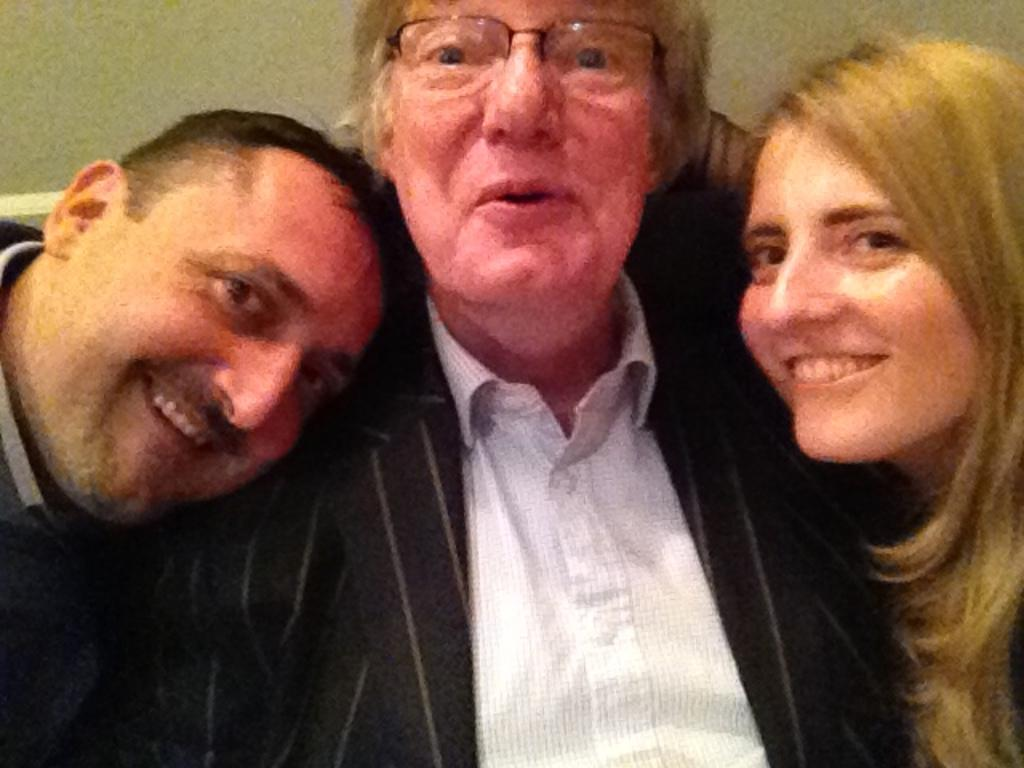How many people are present in the image? There are three people in the image. What is the facial expression of the people in the image? All three people are smiling. Can you describe any specific features of one of the people? One person is wearing spectacles. What can be seen in the background of the image? There is a wall in the background of the image. What type of weather can be seen in the image? The provided facts do not mention any weather conditions, so it cannot be determined from the image. How many legs does the person wearing spectacles have in the image? The provided facts do not mention any specific details about the person's legs, so it cannot be determined from the image. 